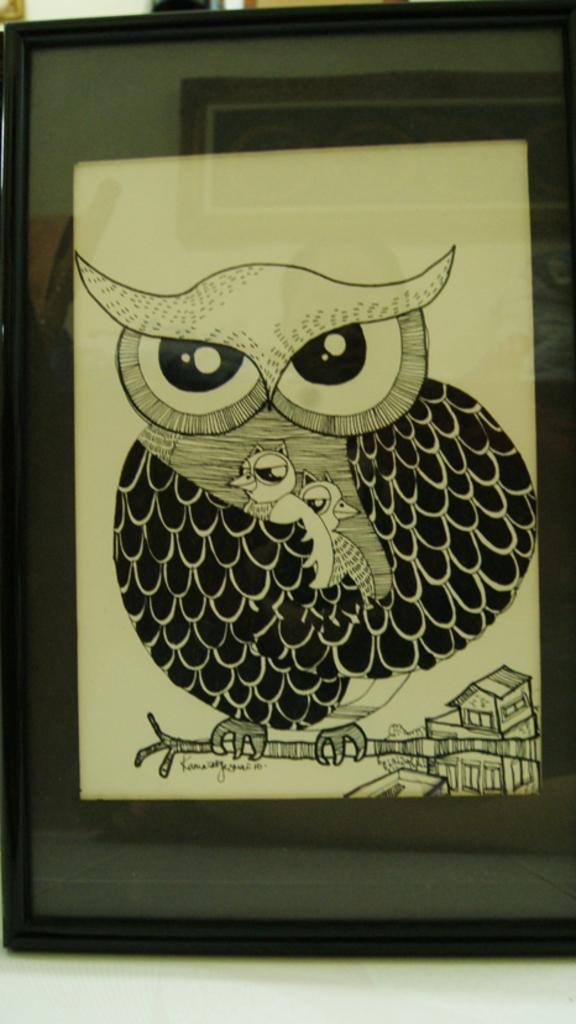In one or two sentences, can you explain what this image depicts? In this image I can see a photo frame which has a glass and a drawing of an owl. 